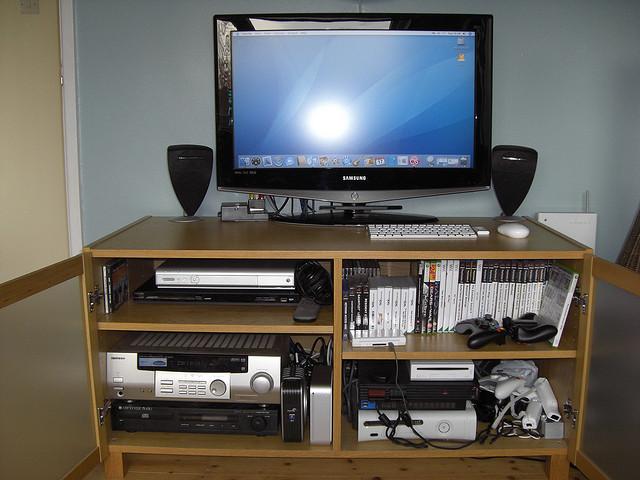Is there a stereo attached to the screen?
Write a very short answer. Yes. Is this equipment still available on today's market?
Be succinct. Yes. Is the monitor on?
Keep it brief. Yes. Is there a keyboard near the screen?
Be succinct. Yes. Is anything alive?
Write a very short answer. No. 